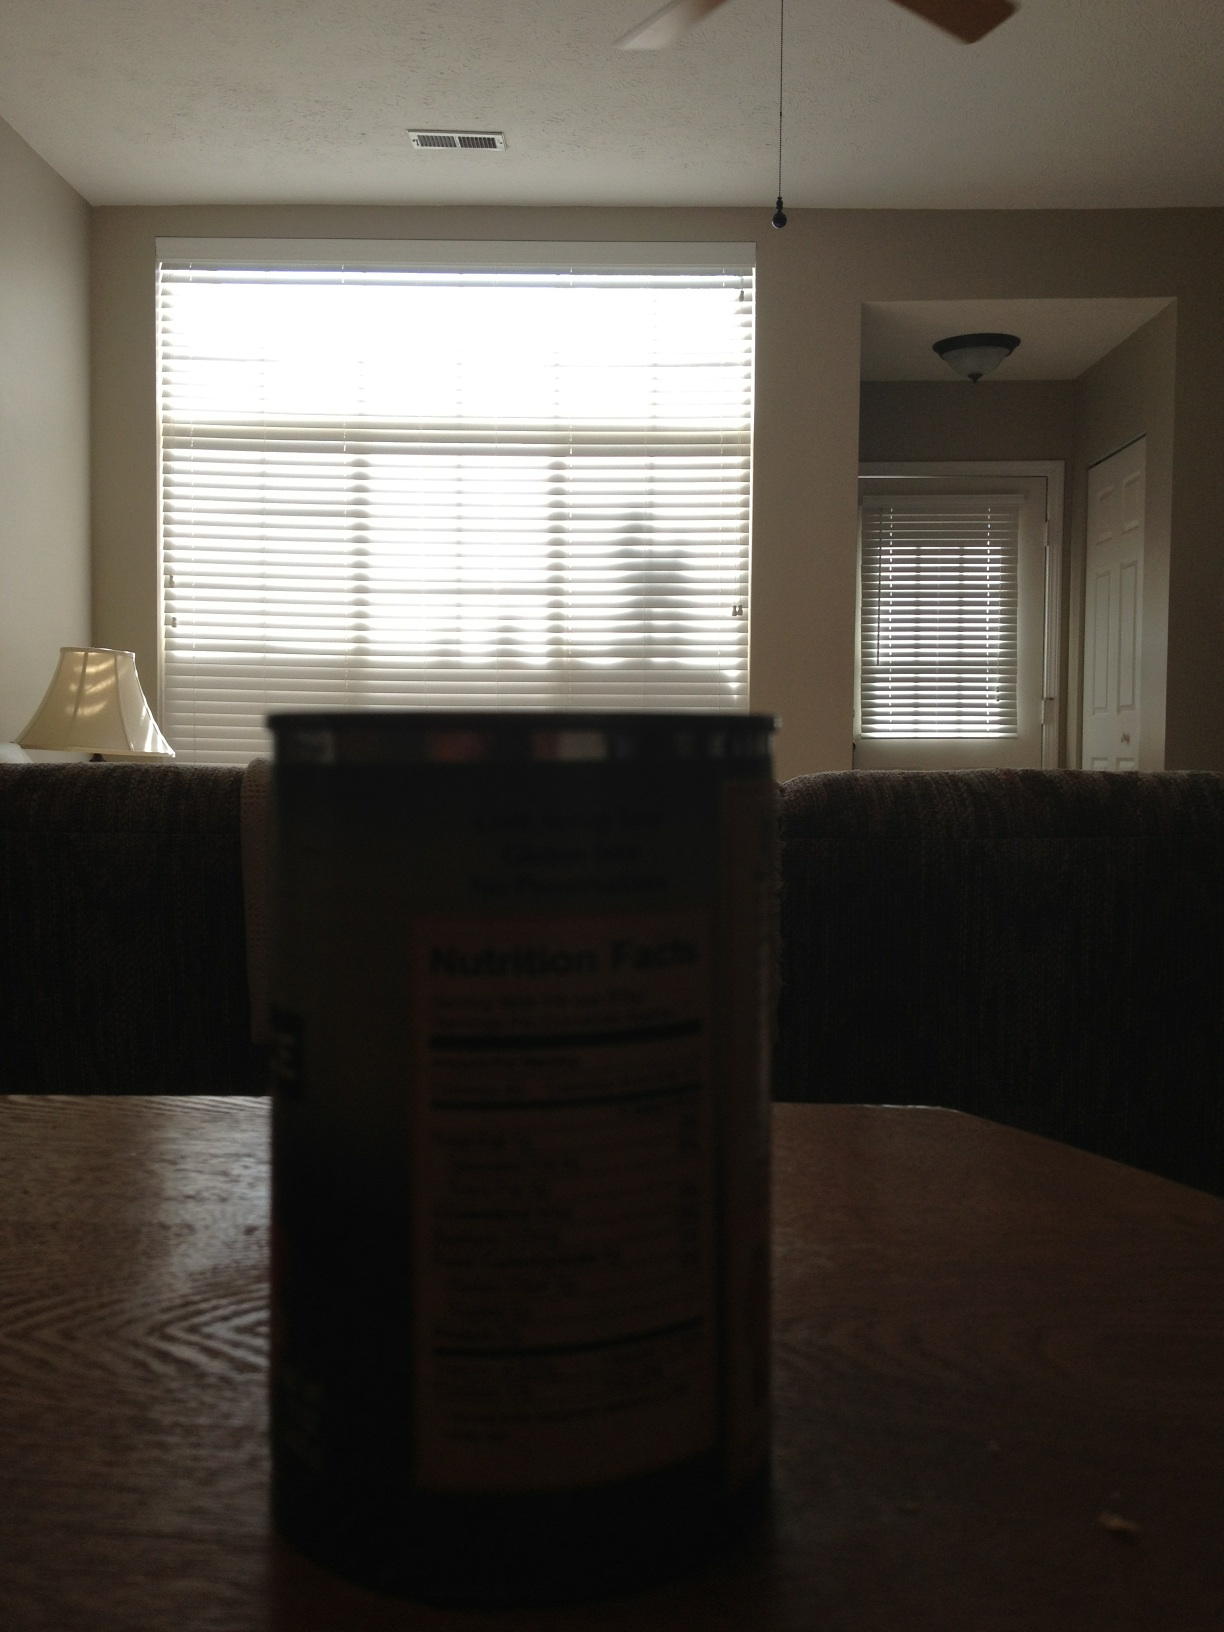Describe a simple, everyday event that might take place here. A simple, everyday event might be someone sorting their groceries on the table, with the can on the foreground being part of the items they are organizing. 